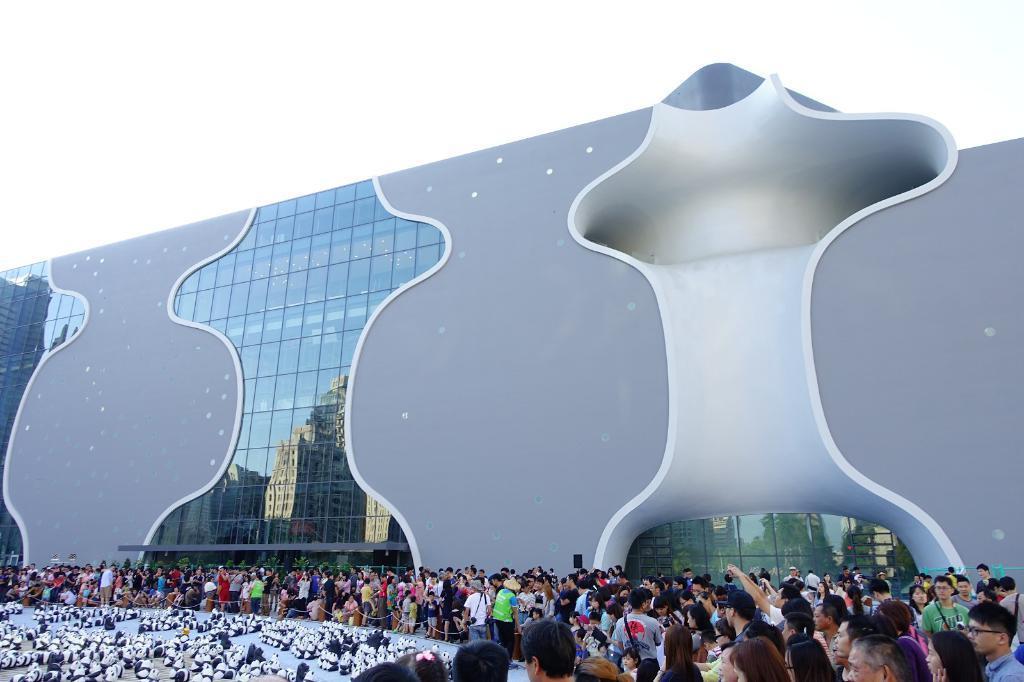How would you summarize this image in a sentence or two? In this image we can see persons standing on the floor, toy pandas, barrier poles, trees, building and sky. 